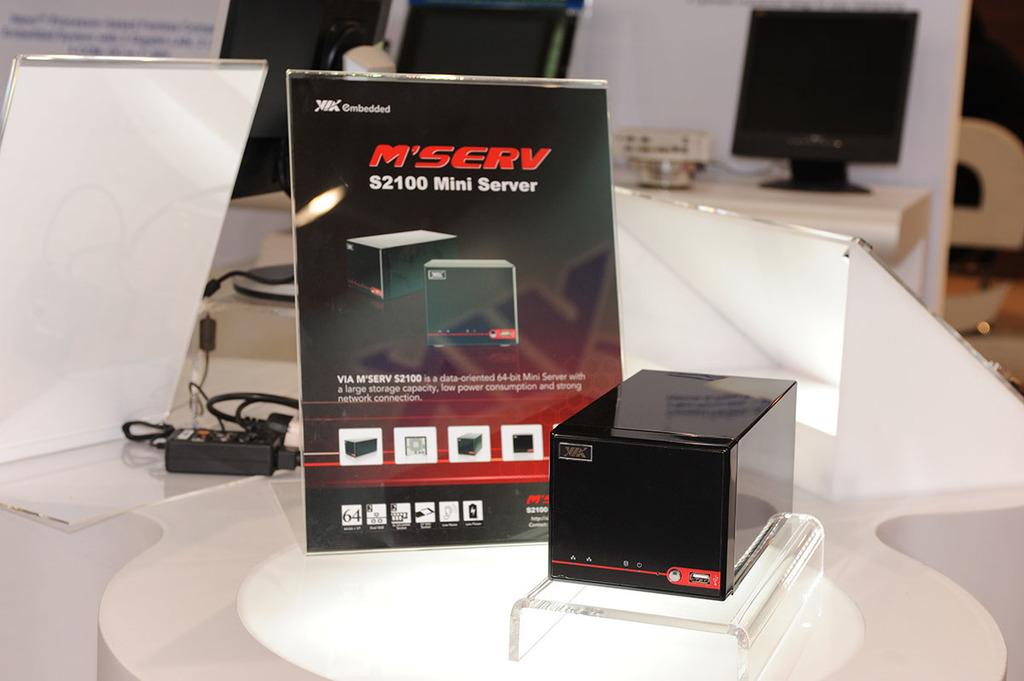What is the name for this device?
Offer a terse response. Mini server. What is the model number of this mini server?
Your answer should be very brief. S2100. 